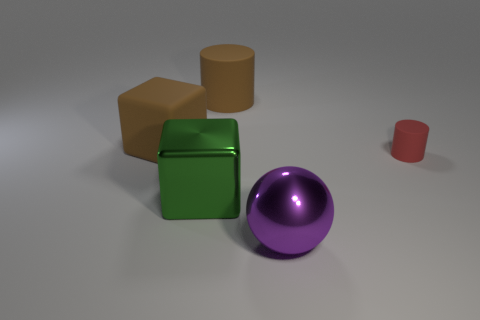How might you categorize these objects? These objects can be categorized based on their geometric properties. We have two cubes: one green and one brown which represent six-faced polyhedrons with equal sides and 90-degree angles. The tan object is a cylinder, characterized by its circular base and straight, parallel sides. The purple object is a perfect sphere, which is fully symmetrical around its center. And the small red object is also a cylinder but much shorter in height, demonstrating how cylinders can vary in proportions. Categorizing these objects by shape helps in understanding their volumetric properties and potential applications. 